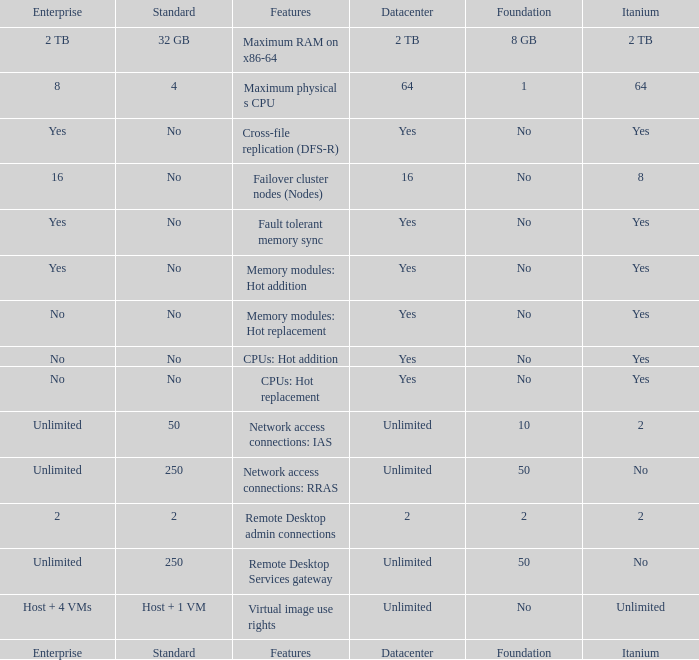Could you help me parse every detail presented in this table? {'header': ['Enterprise', 'Standard', 'Features', 'Datacenter', 'Foundation', 'Itanium'], 'rows': [['2 TB', '32 GB', 'Maximum RAM on x86-64', '2 TB', '8 GB', '2 TB'], ['8', '4', 'Maximum physical s CPU', '64', '1', '64'], ['Yes', 'No', 'Cross-file replication (DFS-R)', 'Yes', 'No', 'Yes'], ['16', 'No', 'Failover cluster nodes (Nodes)', '16', 'No', '8'], ['Yes', 'No', 'Fault tolerant memory sync', 'Yes', 'No', 'Yes'], ['Yes', 'No', 'Memory modules: Hot addition', 'Yes', 'No', 'Yes'], ['No', 'No', 'Memory modules: Hot replacement', 'Yes', 'No', 'Yes'], ['No', 'No', 'CPUs: Hot addition', 'Yes', 'No', 'Yes'], ['No', 'No', 'CPUs: Hot replacement', 'Yes', 'No', 'Yes'], ['Unlimited', '50', 'Network access connections: IAS', 'Unlimited', '10', '2'], ['Unlimited', '250', 'Network access connections: RRAS', 'Unlimited', '50', 'No'], ['2', '2', 'Remote Desktop admin connections', '2', '2', '2'], ['Unlimited', '250', 'Remote Desktop Services gateway', 'Unlimited', '50', 'No'], ['Host + 4 VMs', 'Host + 1 VM', 'Virtual image use rights', 'Unlimited', 'No', 'Unlimited'], ['Enterprise', 'Standard', 'Features', 'Datacenter', 'Foundation', 'Itanium']]} What is the Datacenter for the Fault Tolerant Memory Sync Feature that has Yes for Itanium and No for Standard? Yes. 